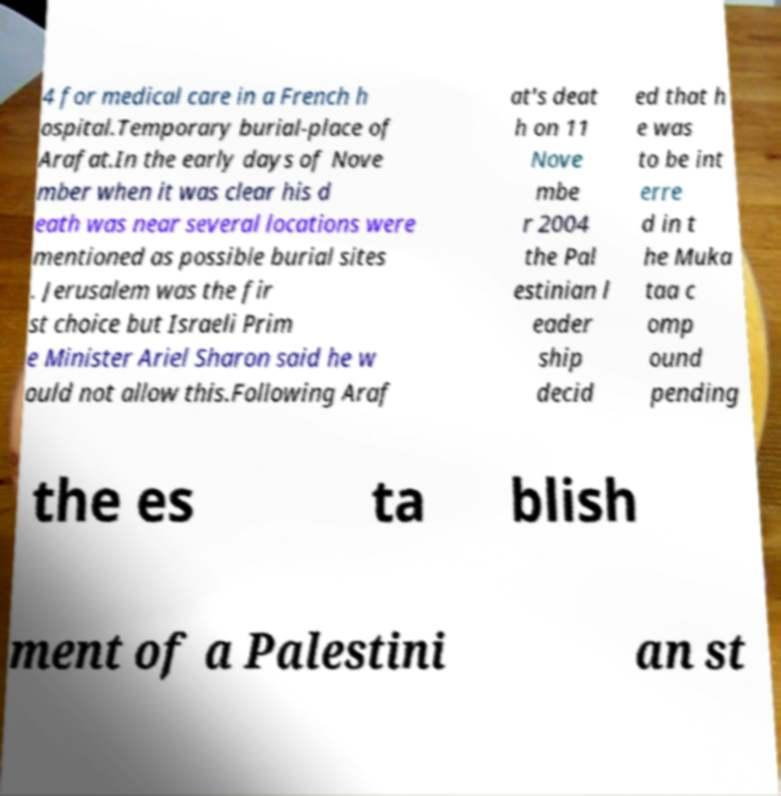There's text embedded in this image that I need extracted. Can you transcribe it verbatim? 4 for medical care in a French h ospital.Temporary burial-place of Arafat.In the early days of Nove mber when it was clear his d eath was near several locations were mentioned as possible burial sites . Jerusalem was the fir st choice but Israeli Prim e Minister Ariel Sharon said he w ould not allow this.Following Araf at's deat h on 11 Nove mbe r 2004 the Pal estinian l eader ship decid ed that h e was to be int erre d in t he Muka taa c omp ound pending the es ta blish ment of a Palestini an st 